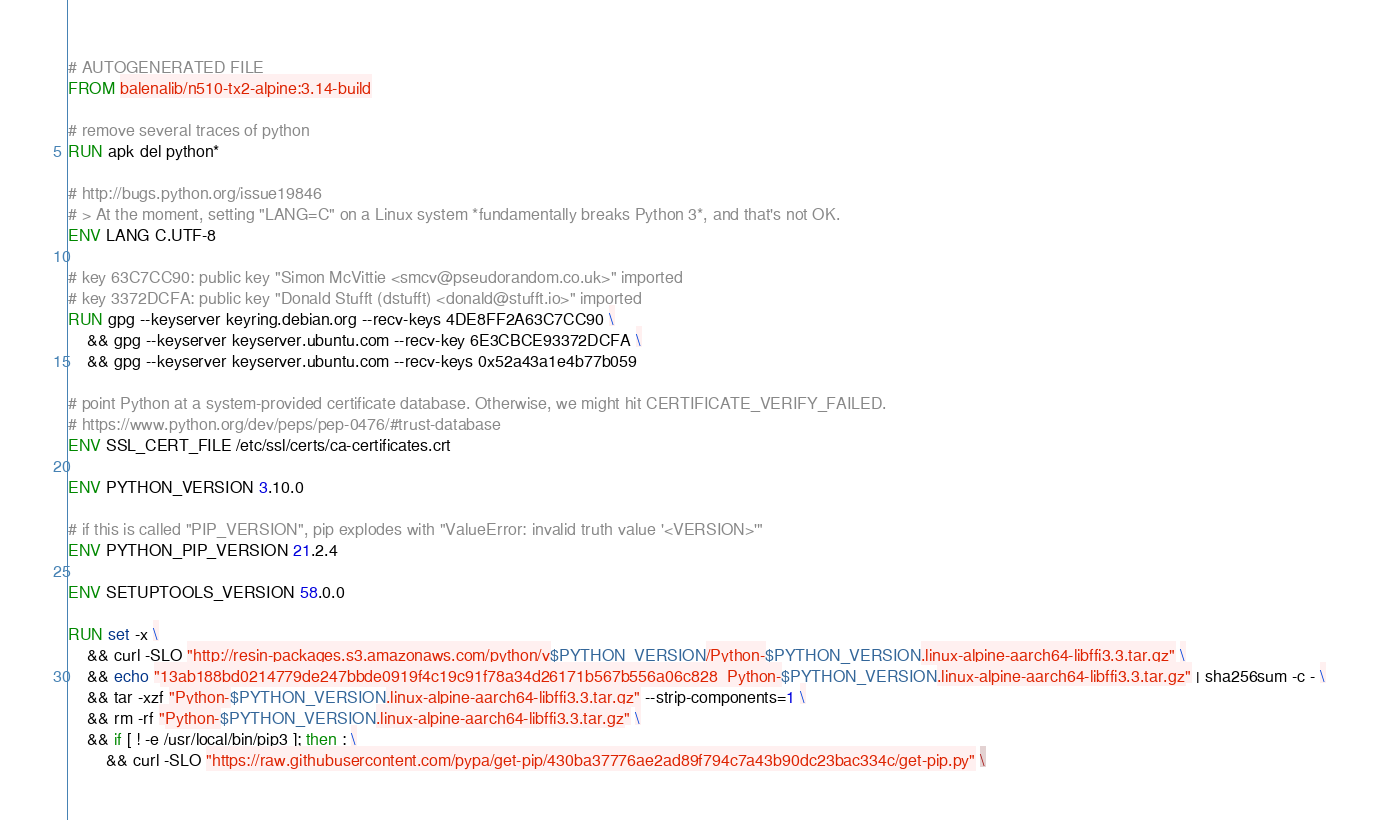<code> <loc_0><loc_0><loc_500><loc_500><_Dockerfile_># AUTOGENERATED FILE
FROM balenalib/n510-tx2-alpine:3.14-build

# remove several traces of python
RUN apk del python*

# http://bugs.python.org/issue19846
# > At the moment, setting "LANG=C" on a Linux system *fundamentally breaks Python 3*, and that's not OK.
ENV LANG C.UTF-8

# key 63C7CC90: public key "Simon McVittie <smcv@pseudorandom.co.uk>" imported
# key 3372DCFA: public key "Donald Stufft (dstufft) <donald@stufft.io>" imported
RUN gpg --keyserver keyring.debian.org --recv-keys 4DE8FF2A63C7CC90 \
	&& gpg --keyserver keyserver.ubuntu.com --recv-key 6E3CBCE93372DCFA \
	&& gpg --keyserver keyserver.ubuntu.com --recv-keys 0x52a43a1e4b77b059

# point Python at a system-provided certificate database. Otherwise, we might hit CERTIFICATE_VERIFY_FAILED.
# https://www.python.org/dev/peps/pep-0476/#trust-database
ENV SSL_CERT_FILE /etc/ssl/certs/ca-certificates.crt

ENV PYTHON_VERSION 3.10.0

# if this is called "PIP_VERSION", pip explodes with "ValueError: invalid truth value '<VERSION>'"
ENV PYTHON_PIP_VERSION 21.2.4

ENV SETUPTOOLS_VERSION 58.0.0

RUN set -x \
	&& curl -SLO "http://resin-packages.s3.amazonaws.com/python/v$PYTHON_VERSION/Python-$PYTHON_VERSION.linux-alpine-aarch64-libffi3.3.tar.gz" \
	&& echo "13ab188bd0214779de247bbde0919f4c19c91f78a34d26171b567b556a06c828  Python-$PYTHON_VERSION.linux-alpine-aarch64-libffi3.3.tar.gz" | sha256sum -c - \
	&& tar -xzf "Python-$PYTHON_VERSION.linux-alpine-aarch64-libffi3.3.tar.gz" --strip-components=1 \
	&& rm -rf "Python-$PYTHON_VERSION.linux-alpine-aarch64-libffi3.3.tar.gz" \
	&& if [ ! -e /usr/local/bin/pip3 ]; then : \
		&& curl -SLO "https://raw.githubusercontent.com/pypa/get-pip/430ba37776ae2ad89f794c7a43b90dc23bac334c/get-pip.py" \</code> 